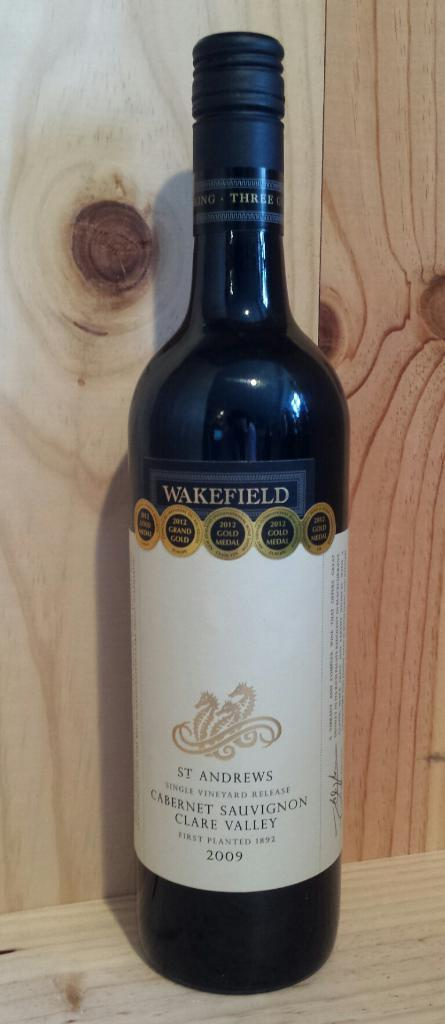<image>
Describe the image concisely. The wine is from St. Andrews and has Wakefield at the top of the label. 